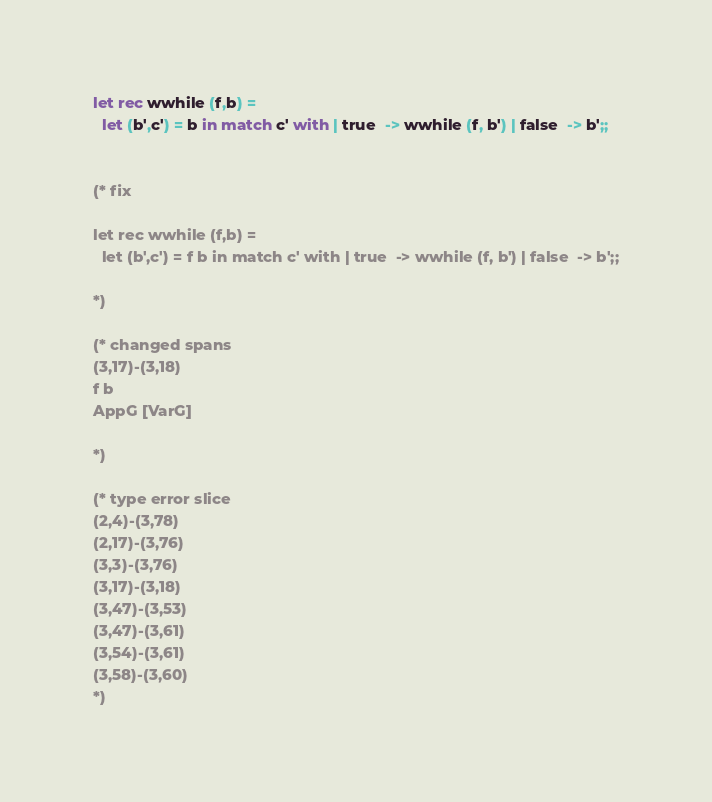Convert code to text. <code><loc_0><loc_0><loc_500><loc_500><_OCaml_>
let rec wwhile (f,b) =
  let (b',c') = b in match c' with | true  -> wwhile (f, b') | false  -> b';;


(* fix

let rec wwhile (f,b) =
  let (b',c') = f b in match c' with | true  -> wwhile (f, b') | false  -> b';;

*)

(* changed spans
(3,17)-(3,18)
f b
AppG [VarG]

*)

(* type error slice
(2,4)-(3,78)
(2,17)-(3,76)
(3,3)-(3,76)
(3,17)-(3,18)
(3,47)-(3,53)
(3,47)-(3,61)
(3,54)-(3,61)
(3,58)-(3,60)
*)
</code> 